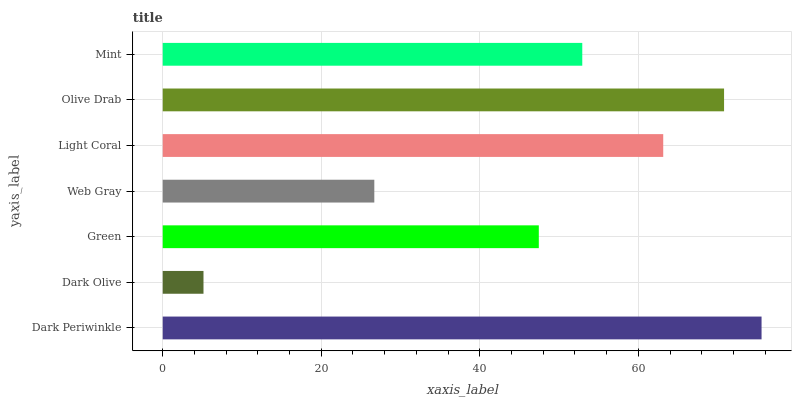Is Dark Olive the minimum?
Answer yes or no. Yes. Is Dark Periwinkle the maximum?
Answer yes or no. Yes. Is Green the minimum?
Answer yes or no. No. Is Green the maximum?
Answer yes or no. No. Is Green greater than Dark Olive?
Answer yes or no. Yes. Is Dark Olive less than Green?
Answer yes or no. Yes. Is Dark Olive greater than Green?
Answer yes or no. No. Is Green less than Dark Olive?
Answer yes or no. No. Is Mint the high median?
Answer yes or no. Yes. Is Mint the low median?
Answer yes or no. Yes. Is Dark Periwinkle the high median?
Answer yes or no. No. Is Green the low median?
Answer yes or no. No. 